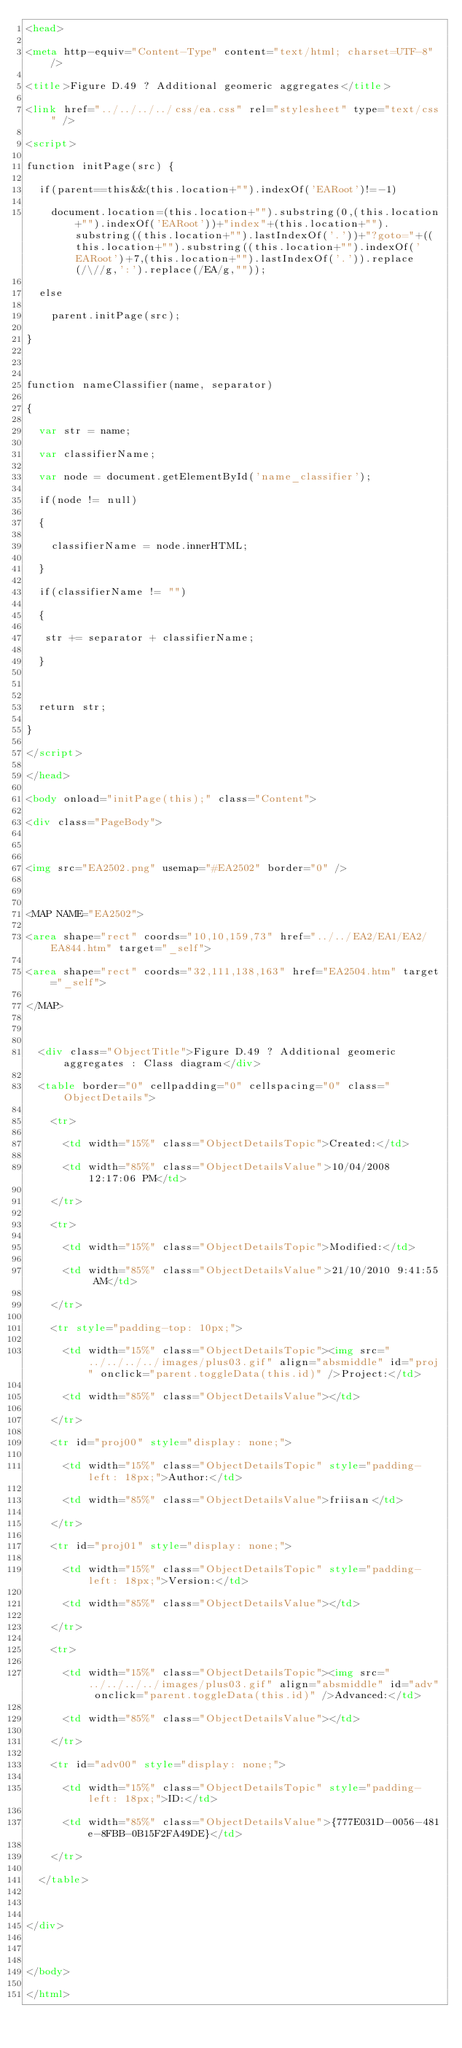<code> <loc_0><loc_0><loc_500><loc_500><_HTML_><head>
<meta http-equiv="Content-Type" content="text/html; charset=UTF-8" />
<title>Figure D.49 ? Additional geomeric aggregates</title>
<link href="../../../../css/ea.css" rel="stylesheet" type="text/css" />
<script>
function initPage(src) {	
	if(parent==this&&(this.location+"").indexOf('EARoot')!=-1)
		document.location=(this.location+"").substring(0,(this.location+"").indexOf('EARoot'))+"index"+(this.location+"").substring((this.location+"").lastIndexOf('.'))+"?goto="+((this.location+"").substring((this.location+"").indexOf('EARoot')+7,(this.location+"").lastIndexOf('.')).replace(/\//g,':').replace(/EA/g,""));
	else
		parent.initPage(src);
}

function nameClassifier(name, separator)
{
  var str = name;
  var classifierName;
  var node = document.getElementById('name_classifier');
  if(node != null)
  {
    classifierName = node.innerHTML;
  }
  if(classifierName != "")
  {
   str += separator + classifierName;
  }
  
  return str;
}
</script>
</head>
<body onload="initPage(this);" class="Content">
<div class="PageBody">
	
<img src="EA2502.png" usemap="#EA2502" border="0" />

<MAP NAME="EA2502">
<area shape="rect" coords="10,10,159,73" href="../../EA2/EA1/EA2/EA844.htm" target="_self">
<area shape="rect" coords="32,111,138,163" href="EA2504.htm" target="_self">
</MAP>

	<div class="ObjectTitle">Figure D.49 ? Additional geomeric aggregates : Class diagram</div>
	<table border="0" cellpadding="0" cellspacing="0" class="ObjectDetails">
		<tr>
			<td width="15%" class="ObjectDetailsTopic">Created:</td>
			<td width="85%" class="ObjectDetailsValue">10/04/2008 12:17:06 PM</td>
		</tr>
		<tr>
			<td width="15%" class="ObjectDetailsTopic">Modified:</td>
			<td width="85%" class="ObjectDetailsValue">21/10/2010 9:41:55 AM</td>
		</tr>
		<tr style="padding-top: 10px;">
			<td width="15%" class="ObjectDetailsTopic"><img src="../../../../images/plus03.gif" align="absmiddle" id="proj" onclick="parent.toggleData(this.id)" />Project:</td>
			<td width="85%" class="ObjectDetailsValue"></td>			
		</tr>
		<tr id="proj00" style="display: none;">
			<td width="15%" class="ObjectDetailsTopic" style="padding-left: 18px;">Author:</td>
			<td width="85%" class="ObjectDetailsValue">friisan</td>
		</tr>
		<tr id="proj01" style="display: none;">
			<td width="15%" class="ObjectDetailsTopic" style="padding-left: 18px;">Version:</td>
			<td width="85%" class="ObjectDetailsValue"></td>
		</tr>
		<tr>
			<td width="15%" class="ObjectDetailsTopic"><img src="../../../../images/plus03.gif" align="absmiddle" id="adv" onclick="parent.toggleData(this.id)" />Advanced:</td>
			<td width="85%" class="ObjectDetailsValue"></td>			
		</tr>
		<tr id="adv00" style="display: none;">
			<td width="15%" class="ObjectDetailsTopic" style="padding-left: 18px;">ID:</td>
			<td width="85%" class="ObjectDetailsValue">{777E031D-0056-481e-8FBB-0B15F2FA49DE}</td>
		</tr>
	</table>
	
</div>
 
</body>
</html></code> 